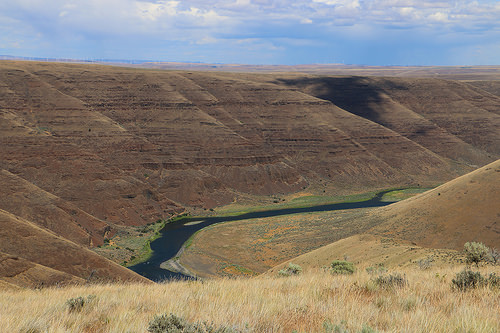<image>
Can you confirm if the river is next to the mountain? Yes. The river is positioned adjacent to the mountain, located nearby in the same general area. 